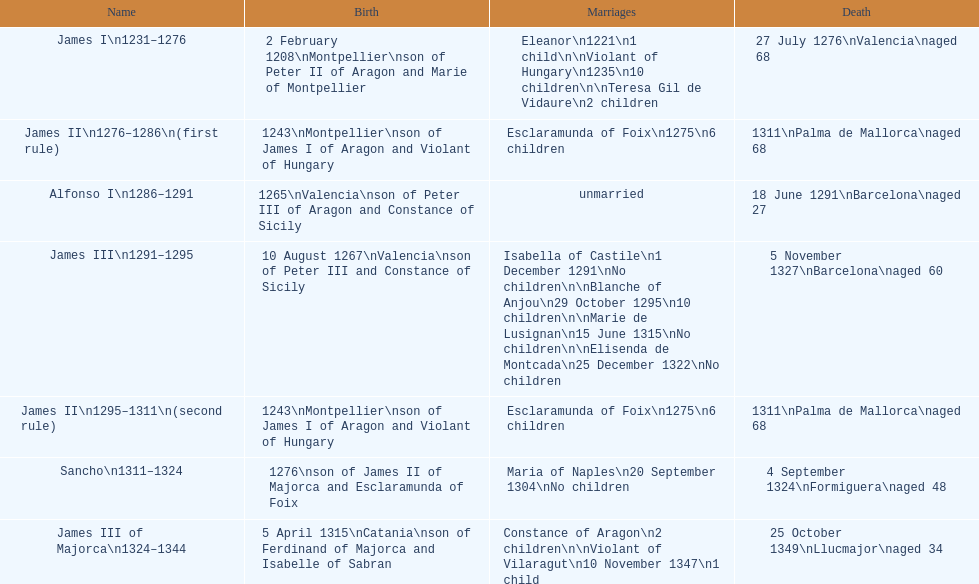How many total marriages did james i have? 3. 